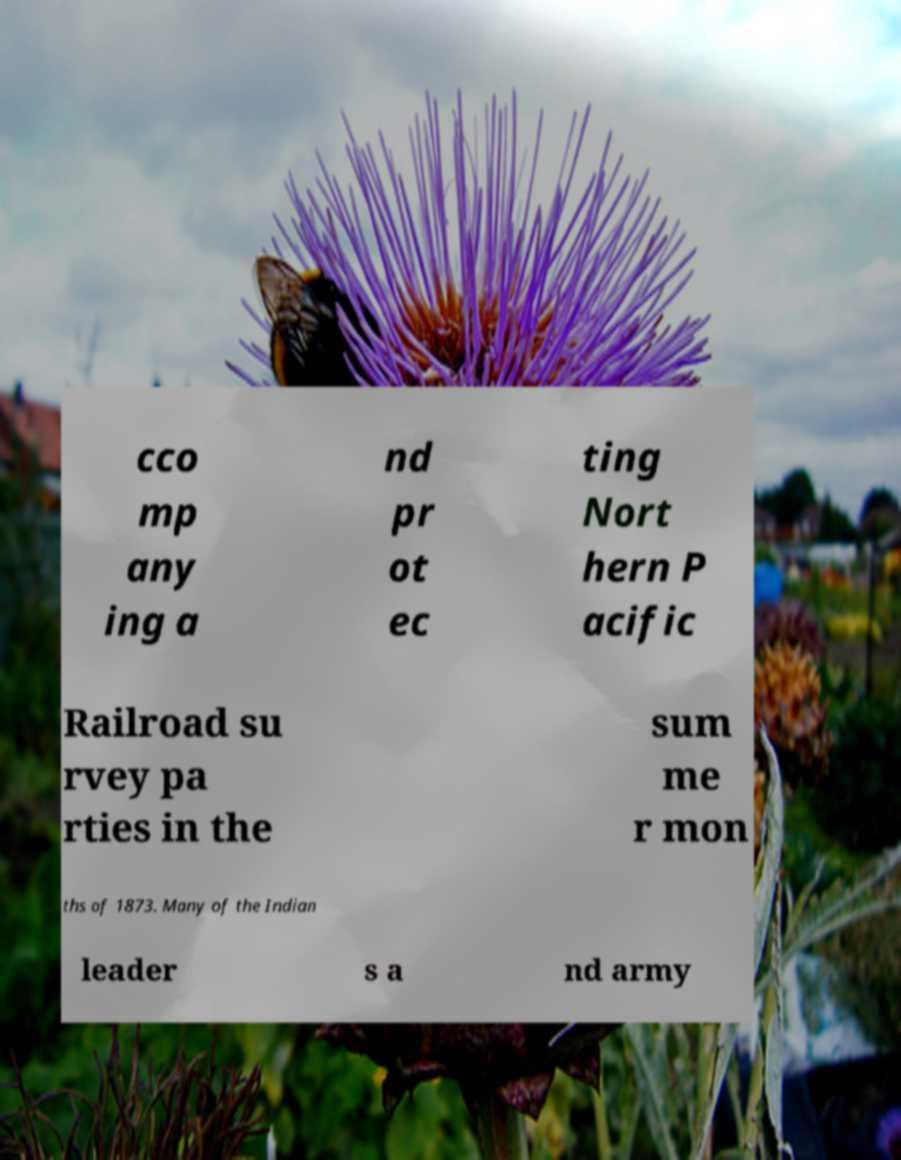There's text embedded in this image that I need extracted. Can you transcribe it verbatim? cco mp any ing a nd pr ot ec ting Nort hern P acific Railroad su rvey pa rties in the sum me r mon ths of 1873. Many of the Indian leader s a nd army 